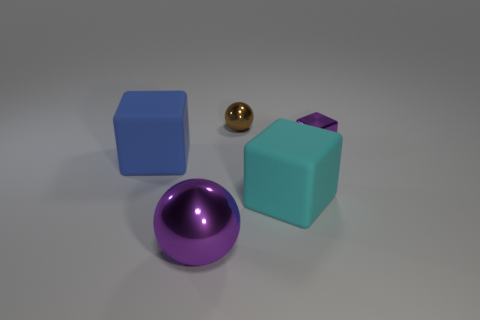Is the color of the shiny cube the same as the object behind the purple block?
Your answer should be very brief. No. Is the number of small metallic spheres that are in front of the cyan cube less than the number of tiny purple things?
Offer a terse response. Yes. There is a purple thing right of the purple metal sphere; what material is it?
Provide a short and direct response. Metal. What number of other things are the same size as the cyan matte object?
Offer a very short reply. 2. There is a cyan cube; does it have the same size as the shiny sphere left of the brown shiny ball?
Give a very brief answer. Yes. The big matte thing on the left side of the sphere behind the matte object that is to the left of the tiny brown object is what shape?
Ensure brevity in your answer.  Cube. Are there fewer tiny purple shiny things than small cyan metallic blocks?
Provide a short and direct response. No. There is a purple metal block; are there any large cubes left of it?
Your response must be concise. Yes. What shape is the thing that is on the left side of the brown object and behind the cyan object?
Make the answer very short. Cube. Is there a cyan rubber thing of the same shape as the blue thing?
Keep it short and to the point. Yes. 